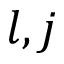<formula> <loc_0><loc_0><loc_500><loc_500>l , j</formula> 